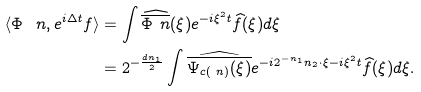Convert formula to latex. <formula><loc_0><loc_0><loc_500><loc_500>\langle \Phi _ { \ } n , e ^ { i \Delta t } f \rangle & = \int \widehat { \overline { \Phi _ { \ } n } } ( \xi ) e ^ { - i \xi ^ { 2 } t } \widehat { f } ( \xi ) d \xi \\ & = 2 ^ { - \frac { d n _ { 1 } } { 2 } } \int \widehat { \overline { \Psi _ { c ( \ n ) } ( \xi ) } } e ^ { - i 2 ^ { - n _ { 1 } } n _ { 2 } \cdot \xi - i \xi ^ { 2 } t } \widehat { f } ( \xi ) d \xi .</formula> 